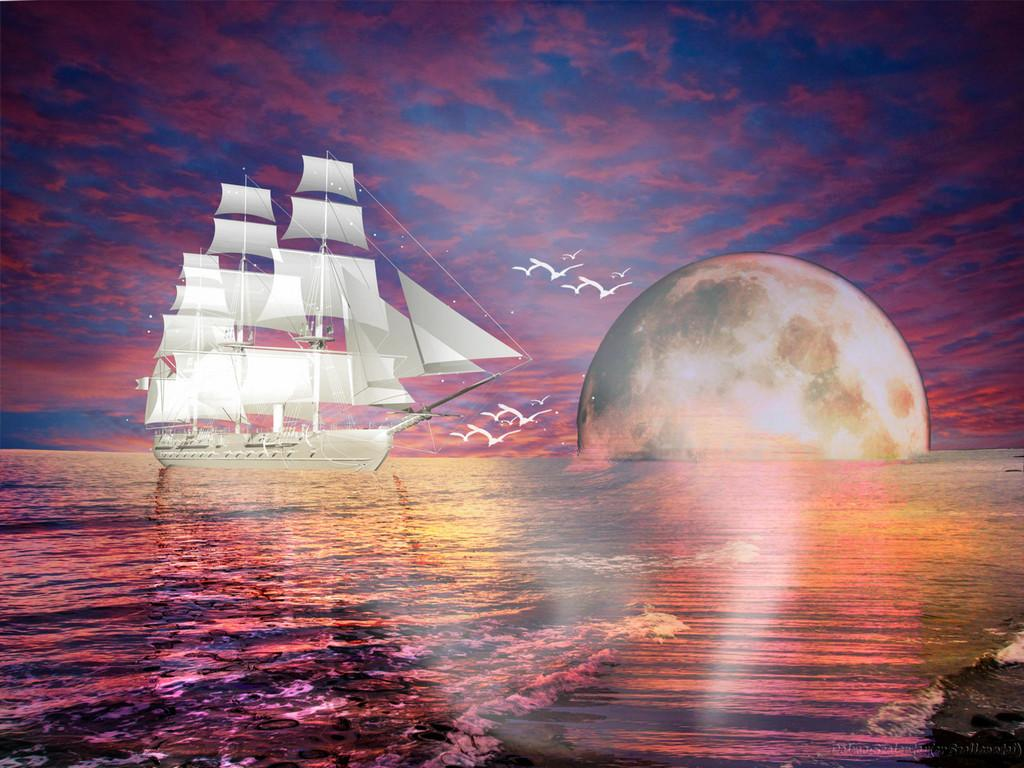What is the main subject of the image? The main subject of the image is a ship. Where is the ship located in the image? The ship is on the water. What is happening with the sun in the image? The sun is going down in the image. How does the ship walk on the water in the image? Ships do not walk; they float on the water. What holiday is being celebrated in the image? There is no indication of a holiday being celebrated in the image. What is the temper of the ship in the image? Ships do not have a temper; they are inanimate objects. 